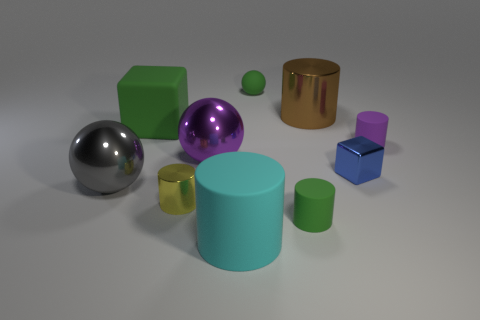The small green rubber thing behind the small metal object left of the blue block behind the gray ball is what shape?
Make the answer very short. Sphere. The small matte thing that is on the left side of the small purple matte thing and in front of the tiny sphere has what shape?
Offer a terse response. Cylinder. Is there a big object that has the same material as the small purple cylinder?
Keep it short and to the point. Yes. The ball that is the same color as the rubber cube is what size?
Make the answer very short. Small. There is a big metallic object that is to the right of the tiny green ball; what is its color?
Provide a short and direct response. Brown. Does the tiny yellow object have the same shape as the tiny green rubber thing in front of the small matte sphere?
Keep it short and to the point. Yes. Are there any tiny matte things that have the same color as the tiny rubber sphere?
Ensure brevity in your answer.  Yes. What size is the purple object that is the same material as the tiny green sphere?
Ensure brevity in your answer.  Small. Does the matte block have the same color as the small shiny cube?
Your answer should be compact. No. There is a big metallic object left of the purple shiny sphere; is its shape the same as the tiny purple thing?
Give a very brief answer. No. 